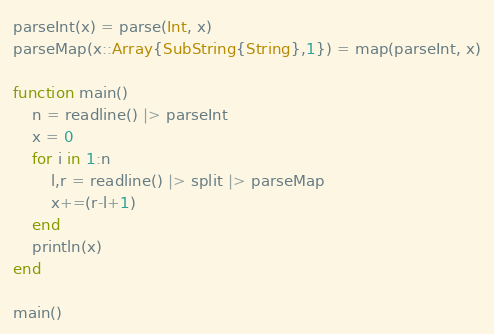<code> <loc_0><loc_0><loc_500><loc_500><_Julia_>parseInt(x) = parse(Int, x)
parseMap(x::Array{SubString{String},1}) = map(parseInt, x)

function main()
	n = readline() |> parseInt
	x = 0
	for i in 1:n
		l,r = readline() |> split |> parseMap
		x+=(r-l+1)
	end
	println(x)
end

main()</code> 